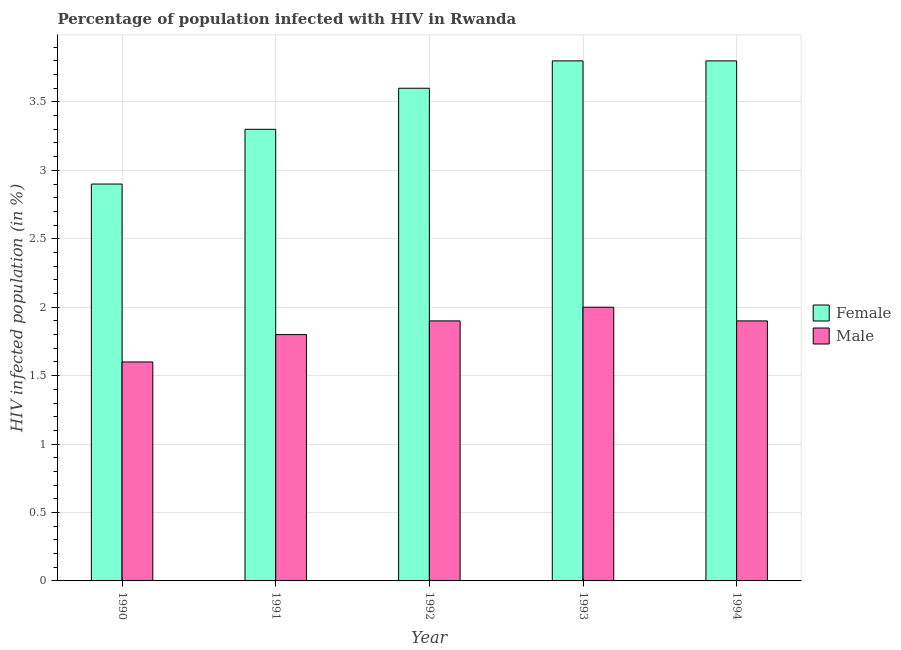How many different coloured bars are there?
Your answer should be compact. 2. How many groups of bars are there?
Ensure brevity in your answer.  5. How many bars are there on the 4th tick from the left?
Offer a terse response. 2. What is the label of the 1st group of bars from the left?
Provide a short and direct response. 1990. Across all years, what is the maximum percentage of males who are infected with hiv?
Your answer should be compact. 2. In which year was the percentage of females who are infected with hiv maximum?
Offer a very short reply. 1993. In which year was the percentage of females who are infected with hiv minimum?
Give a very brief answer. 1990. What is the total percentage of males who are infected with hiv in the graph?
Your answer should be compact. 9.2. What is the difference between the percentage of females who are infected with hiv in 1991 and that in 1993?
Offer a very short reply. -0.5. What is the difference between the percentage of females who are infected with hiv in 1992 and the percentage of males who are infected with hiv in 1991?
Ensure brevity in your answer.  0.3. What is the average percentage of females who are infected with hiv per year?
Provide a short and direct response. 3.48. What is the ratio of the percentage of females who are infected with hiv in 1992 to that in 1993?
Provide a succinct answer. 0.95. What is the difference between the highest and the second highest percentage of males who are infected with hiv?
Make the answer very short. 0.1. What is the difference between the highest and the lowest percentage of males who are infected with hiv?
Offer a terse response. 0.4. What does the 2nd bar from the left in 1993 represents?
Give a very brief answer. Male. Are all the bars in the graph horizontal?
Give a very brief answer. No. How many years are there in the graph?
Offer a terse response. 5. What is the difference between two consecutive major ticks on the Y-axis?
Provide a succinct answer. 0.5. Are the values on the major ticks of Y-axis written in scientific E-notation?
Offer a terse response. No. Does the graph contain grids?
Your answer should be compact. Yes. How many legend labels are there?
Provide a succinct answer. 2. How are the legend labels stacked?
Offer a terse response. Vertical. What is the title of the graph?
Provide a short and direct response. Percentage of population infected with HIV in Rwanda. Does "Private credit bureau" appear as one of the legend labels in the graph?
Offer a terse response. No. What is the label or title of the Y-axis?
Make the answer very short. HIV infected population (in %). What is the HIV infected population (in %) of Female in 1990?
Keep it short and to the point. 2.9. What is the HIV infected population (in %) in Male in 1990?
Give a very brief answer. 1.6. What is the HIV infected population (in %) of Male in 1991?
Make the answer very short. 1.8. What is the HIV infected population (in %) in Male in 1992?
Offer a terse response. 1.9. Across all years, what is the maximum HIV infected population (in %) of Male?
Offer a very short reply. 2. What is the total HIV infected population (in %) in Female in the graph?
Offer a terse response. 17.4. What is the difference between the HIV infected population (in %) of Male in 1990 and that in 1992?
Your answer should be compact. -0.3. What is the difference between the HIV infected population (in %) in Male in 1990 and that in 1993?
Your answer should be compact. -0.4. What is the difference between the HIV infected population (in %) of Female in 1991 and that in 1992?
Your answer should be compact. -0.3. What is the difference between the HIV infected population (in %) in Female in 1991 and that in 1993?
Provide a short and direct response. -0.5. What is the difference between the HIV infected population (in %) in Female in 1992 and that in 1993?
Your response must be concise. -0.2. What is the difference between the HIV infected population (in %) of Male in 1992 and that in 1994?
Your answer should be very brief. 0. What is the difference between the HIV infected population (in %) of Female in 1990 and the HIV infected population (in %) of Male in 1991?
Make the answer very short. 1.1. What is the difference between the HIV infected population (in %) of Female in 1990 and the HIV infected population (in %) of Male in 1992?
Offer a terse response. 1. What is the difference between the HIV infected population (in %) in Female in 1990 and the HIV infected population (in %) in Male in 1993?
Ensure brevity in your answer.  0.9. What is the difference between the HIV infected population (in %) in Female in 1990 and the HIV infected population (in %) in Male in 1994?
Ensure brevity in your answer.  1. What is the difference between the HIV infected population (in %) of Female in 1991 and the HIV infected population (in %) of Male in 1993?
Provide a succinct answer. 1.3. What is the difference between the HIV infected population (in %) of Female in 1991 and the HIV infected population (in %) of Male in 1994?
Provide a short and direct response. 1.4. What is the difference between the HIV infected population (in %) in Female in 1992 and the HIV infected population (in %) in Male in 1993?
Give a very brief answer. 1.6. What is the difference between the HIV infected population (in %) in Female in 1992 and the HIV infected population (in %) in Male in 1994?
Give a very brief answer. 1.7. What is the average HIV infected population (in %) of Female per year?
Provide a short and direct response. 3.48. What is the average HIV infected population (in %) of Male per year?
Offer a very short reply. 1.84. In the year 1991, what is the difference between the HIV infected population (in %) of Female and HIV infected population (in %) of Male?
Keep it short and to the point. 1.5. In the year 1993, what is the difference between the HIV infected population (in %) in Female and HIV infected population (in %) in Male?
Ensure brevity in your answer.  1.8. In the year 1994, what is the difference between the HIV infected population (in %) in Female and HIV infected population (in %) in Male?
Offer a terse response. 1.9. What is the ratio of the HIV infected population (in %) of Female in 1990 to that in 1991?
Offer a terse response. 0.88. What is the ratio of the HIV infected population (in %) of Female in 1990 to that in 1992?
Provide a short and direct response. 0.81. What is the ratio of the HIV infected population (in %) of Male in 1990 to that in 1992?
Keep it short and to the point. 0.84. What is the ratio of the HIV infected population (in %) of Female in 1990 to that in 1993?
Your answer should be very brief. 0.76. What is the ratio of the HIV infected population (in %) of Female in 1990 to that in 1994?
Offer a terse response. 0.76. What is the ratio of the HIV infected population (in %) of Male in 1990 to that in 1994?
Ensure brevity in your answer.  0.84. What is the ratio of the HIV infected population (in %) in Female in 1991 to that in 1992?
Provide a succinct answer. 0.92. What is the ratio of the HIV infected population (in %) of Female in 1991 to that in 1993?
Give a very brief answer. 0.87. What is the ratio of the HIV infected population (in %) in Male in 1991 to that in 1993?
Your response must be concise. 0.9. What is the ratio of the HIV infected population (in %) of Female in 1991 to that in 1994?
Provide a succinct answer. 0.87. What is the ratio of the HIV infected population (in %) in Male in 1991 to that in 1994?
Your answer should be very brief. 0.95. What is the ratio of the HIV infected population (in %) in Female in 1992 to that in 1994?
Make the answer very short. 0.95. What is the ratio of the HIV infected population (in %) of Female in 1993 to that in 1994?
Your response must be concise. 1. What is the ratio of the HIV infected population (in %) of Male in 1993 to that in 1994?
Give a very brief answer. 1.05. What is the difference between the highest and the second highest HIV infected population (in %) of Male?
Your answer should be very brief. 0.1. What is the difference between the highest and the lowest HIV infected population (in %) of Female?
Ensure brevity in your answer.  0.9. What is the difference between the highest and the lowest HIV infected population (in %) in Male?
Your response must be concise. 0.4. 